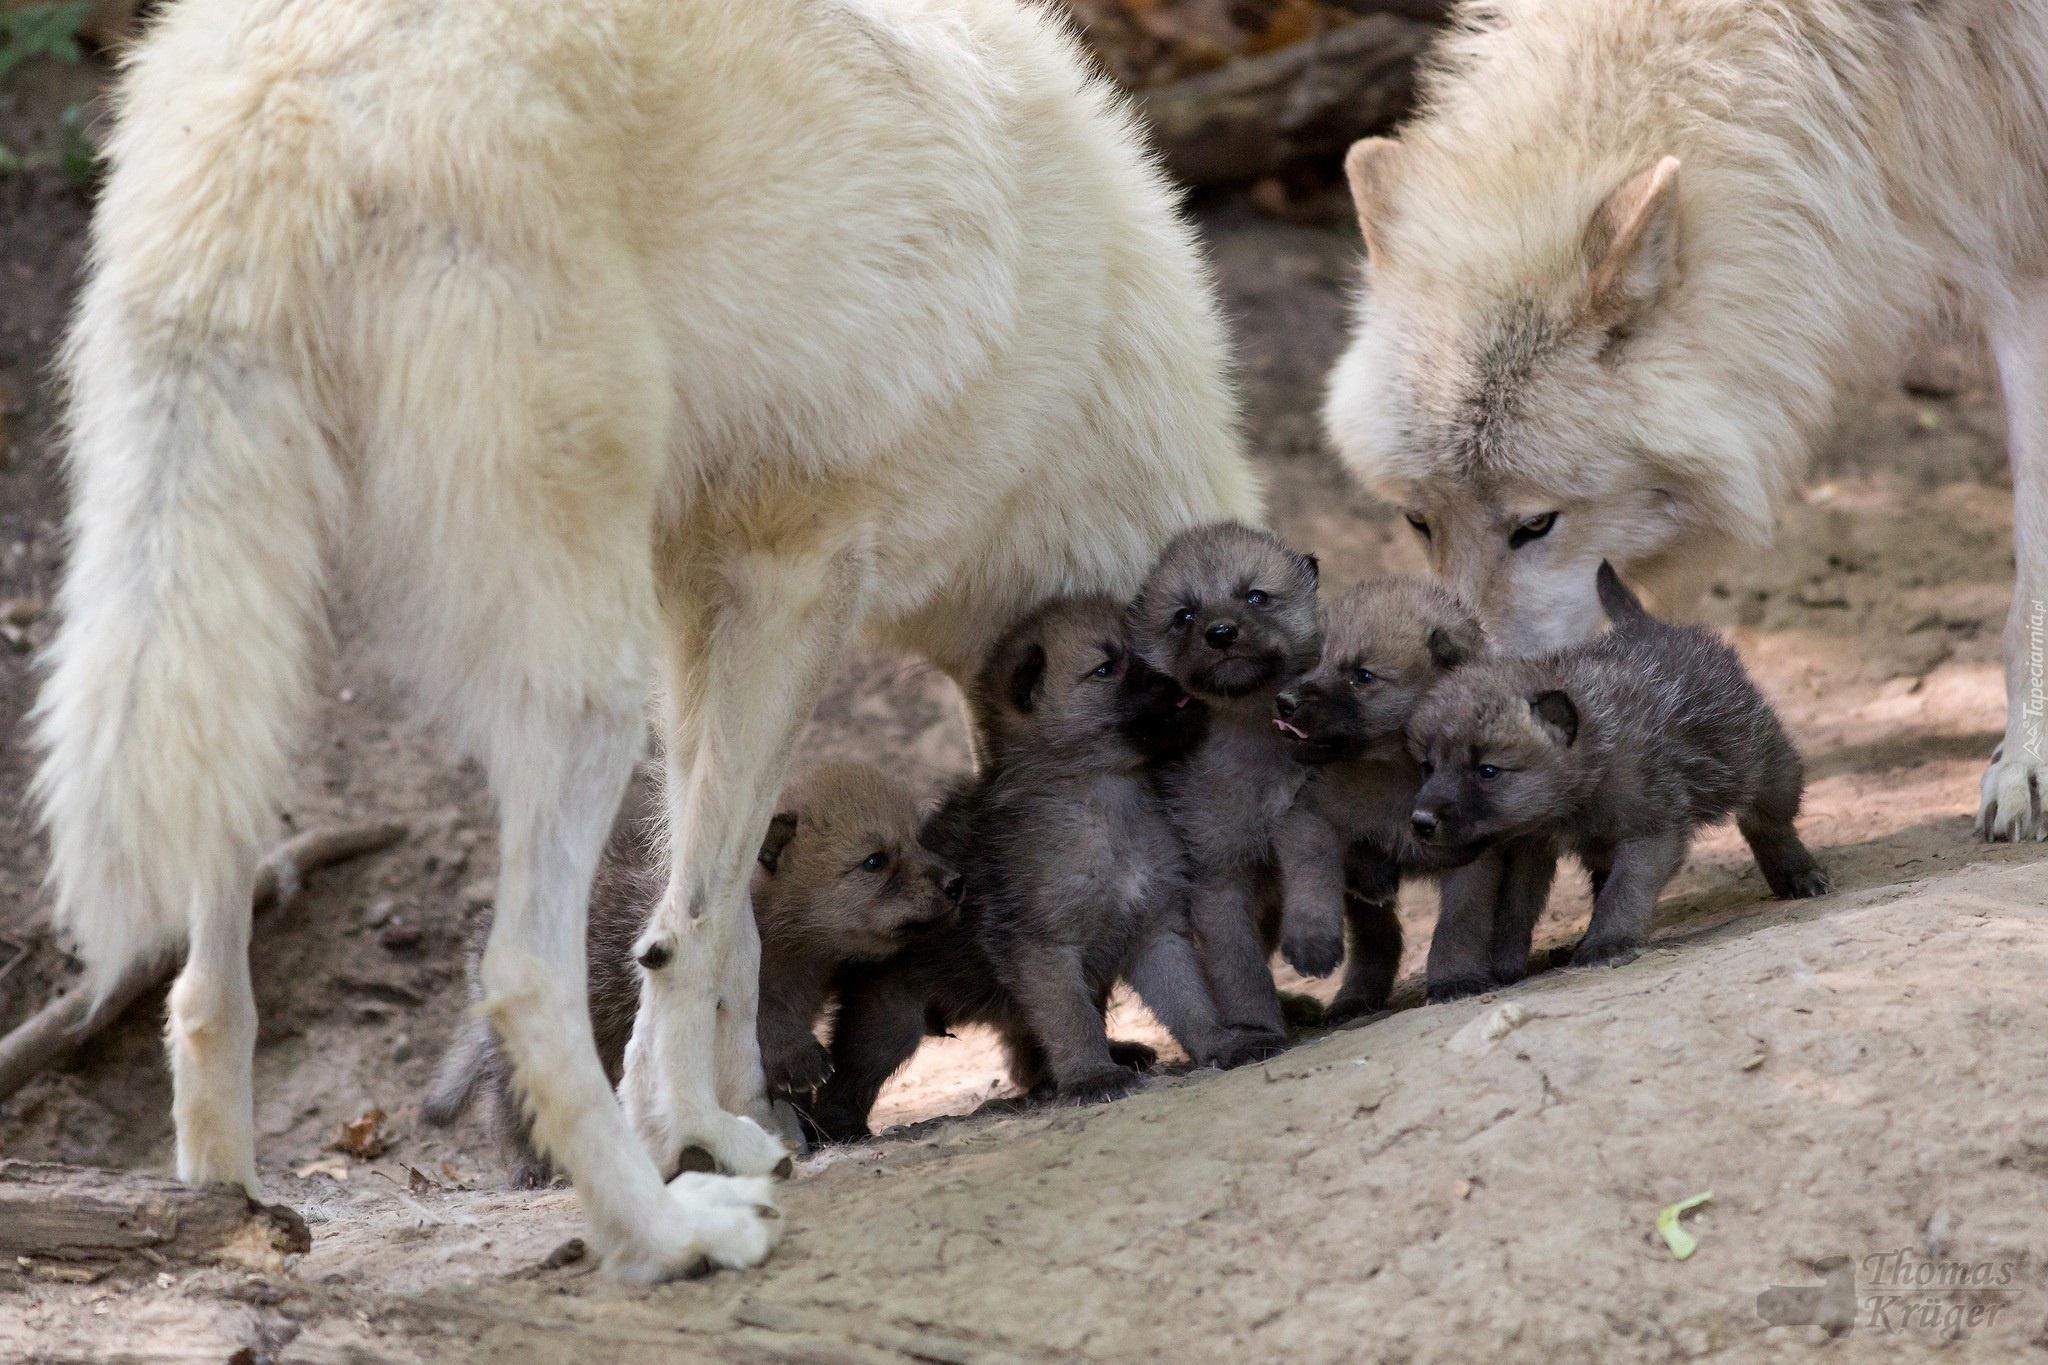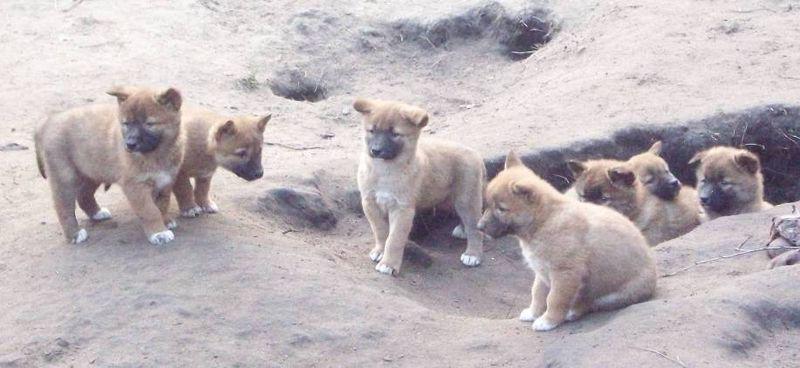The first image is the image on the left, the second image is the image on the right. Assess this claim about the two images: "Some of the animals in the image on the left are lying on the green grass.". Correct or not? Answer yes or no. No. The first image is the image on the left, the second image is the image on the right. Analyze the images presented: Is the assertion "Each image includes canine pups, and at least one image also includes at least one adult dog." valid? Answer yes or no. Yes. 